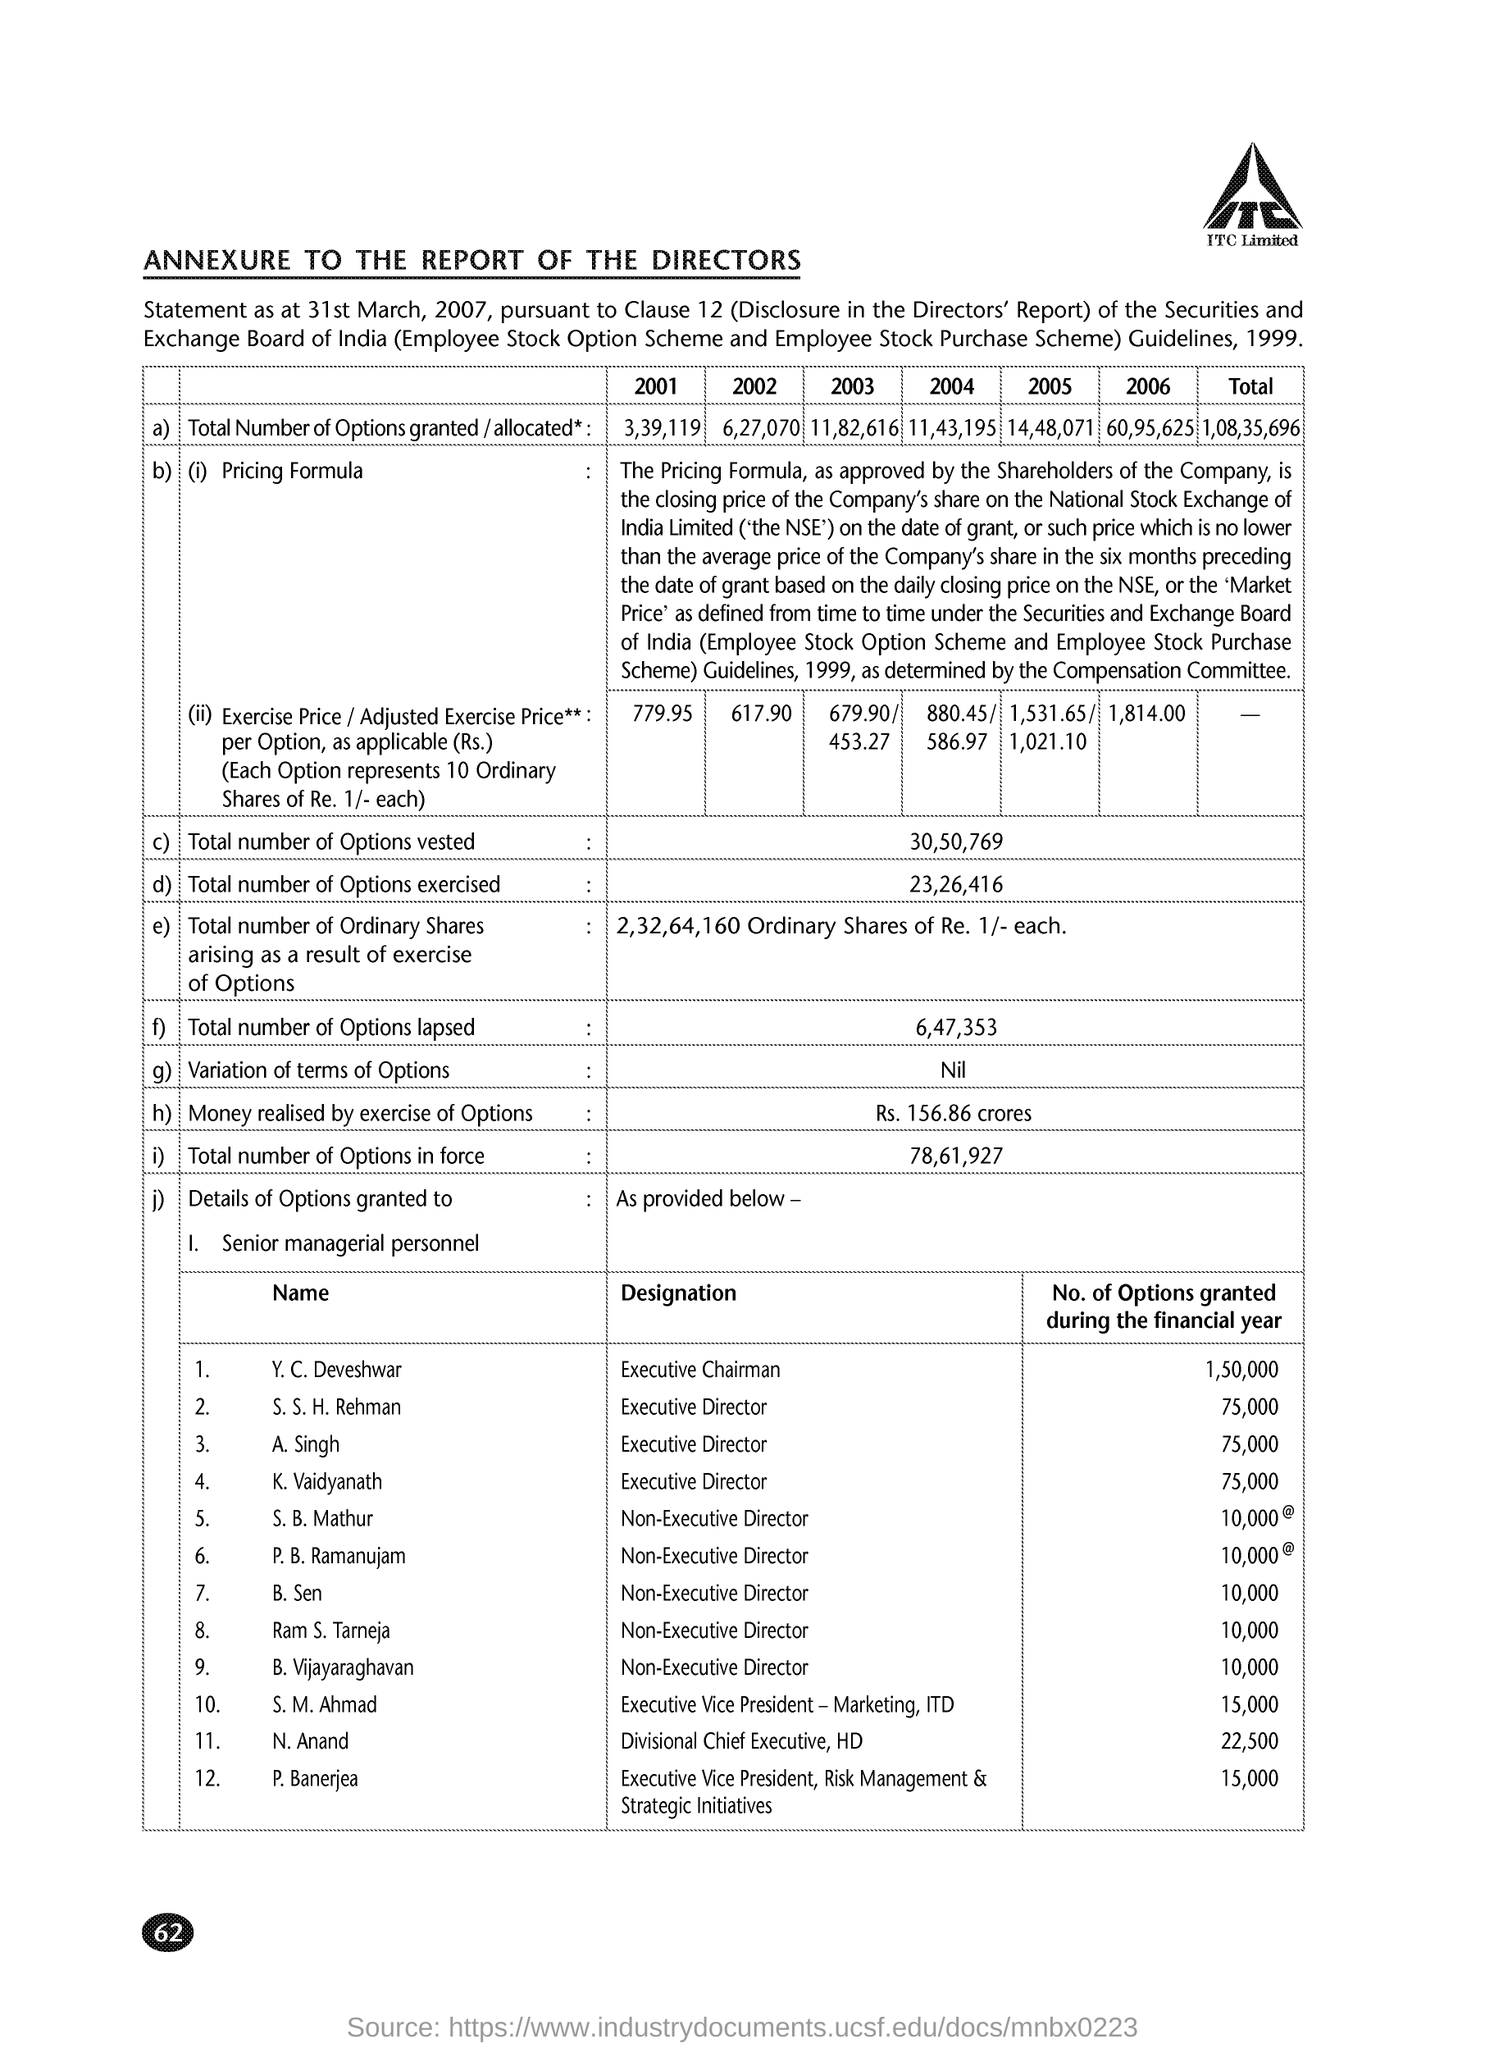Identify some key points in this picture. During the financial year, a total of 10,000 options were granted to B. Sen. During the financial year, a total of 10,000 options were granted to S. B. Mathur. In total, 23,26,416 options were exercised. The number of options granted during the financial year for A. Singh was 75,000. As of the current date, there have been a total of 6,47,353 options that have lapsed. 